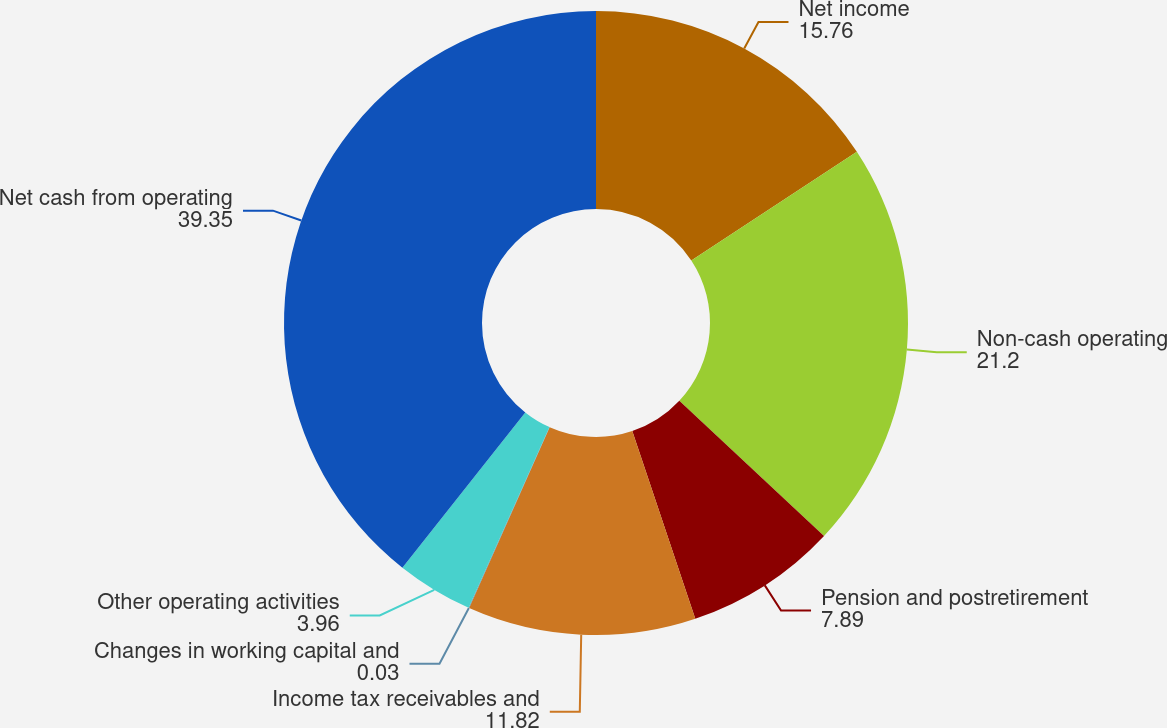Convert chart to OTSL. <chart><loc_0><loc_0><loc_500><loc_500><pie_chart><fcel>Net income<fcel>Non-cash operating<fcel>Pension and postretirement<fcel>Income tax receivables and<fcel>Changes in working capital and<fcel>Other operating activities<fcel>Net cash from operating<nl><fcel>15.76%<fcel>21.2%<fcel>7.89%<fcel>11.82%<fcel>0.03%<fcel>3.96%<fcel>39.35%<nl></chart> 